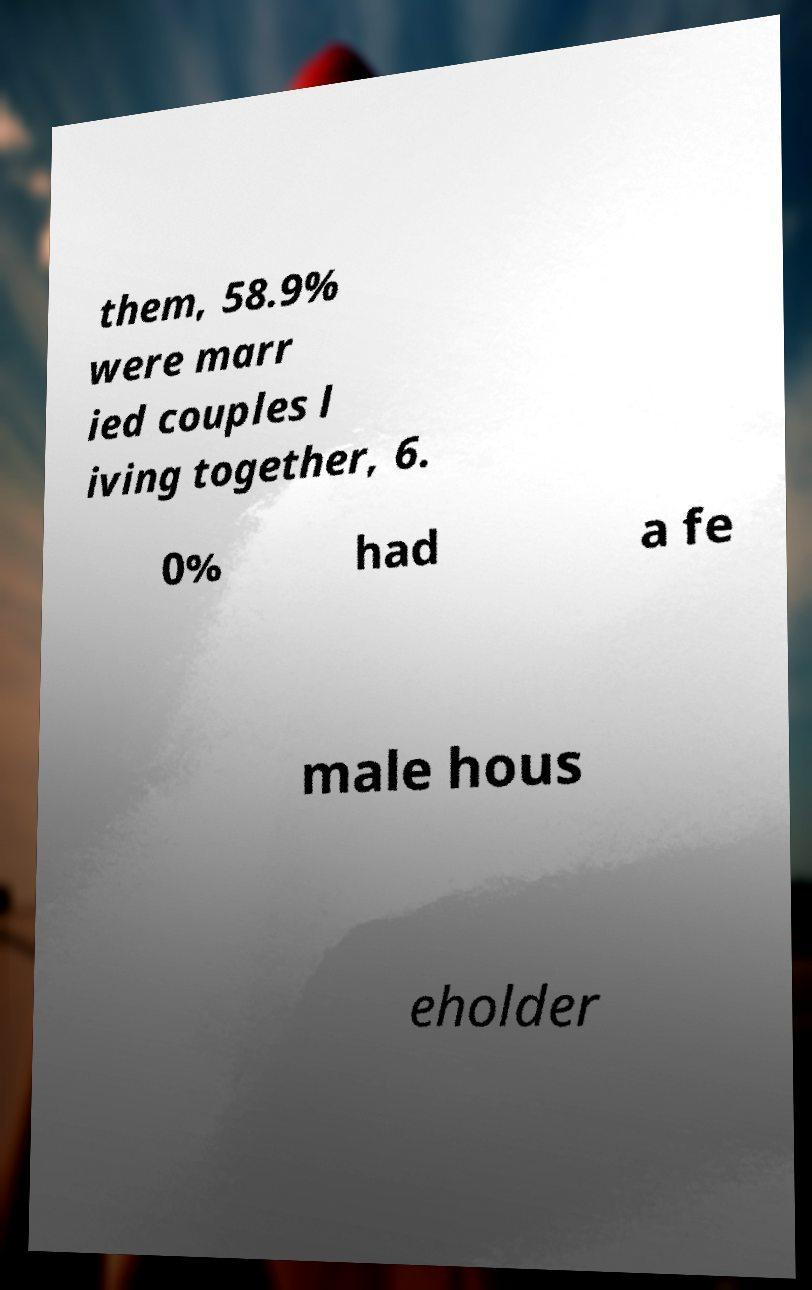Please read and relay the text visible in this image. What does it say? them, 58.9% were marr ied couples l iving together, 6. 0% had a fe male hous eholder 